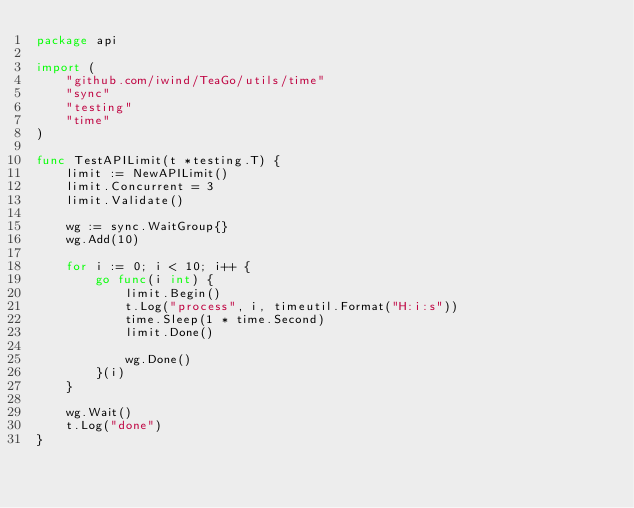<code> <loc_0><loc_0><loc_500><loc_500><_Go_>package api

import (
	"github.com/iwind/TeaGo/utils/time"
	"sync"
	"testing"
	"time"
)

func TestAPILimit(t *testing.T) {
	limit := NewAPILimit()
	limit.Concurrent = 3
	limit.Validate()

	wg := sync.WaitGroup{}
	wg.Add(10)

	for i := 0; i < 10; i++ {
		go func(i int) {
			limit.Begin()
			t.Log("process", i, timeutil.Format("H:i:s"))
			time.Sleep(1 * time.Second)
			limit.Done()

			wg.Done()
		}(i)
	}

	wg.Wait()
	t.Log("done")
}
</code> 